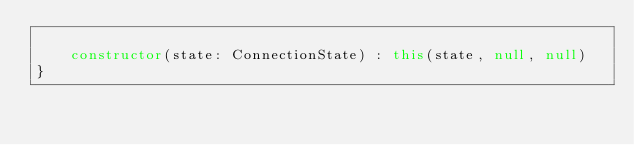<code> <loc_0><loc_0><loc_500><loc_500><_Kotlin_>
    constructor(state: ConnectionState) : this(state, null, null)
}</code> 